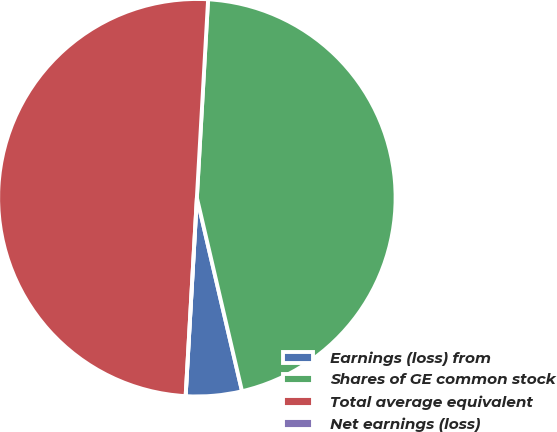Convert chart to OTSL. <chart><loc_0><loc_0><loc_500><loc_500><pie_chart><fcel>Earnings (loss) from<fcel>Shares of GE common stock<fcel>Total average equivalent<fcel>Net earnings (loss)<nl><fcel>4.55%<fcel>45.45%<fcel>50.0%<fcel>0.0%<nl></chart> 